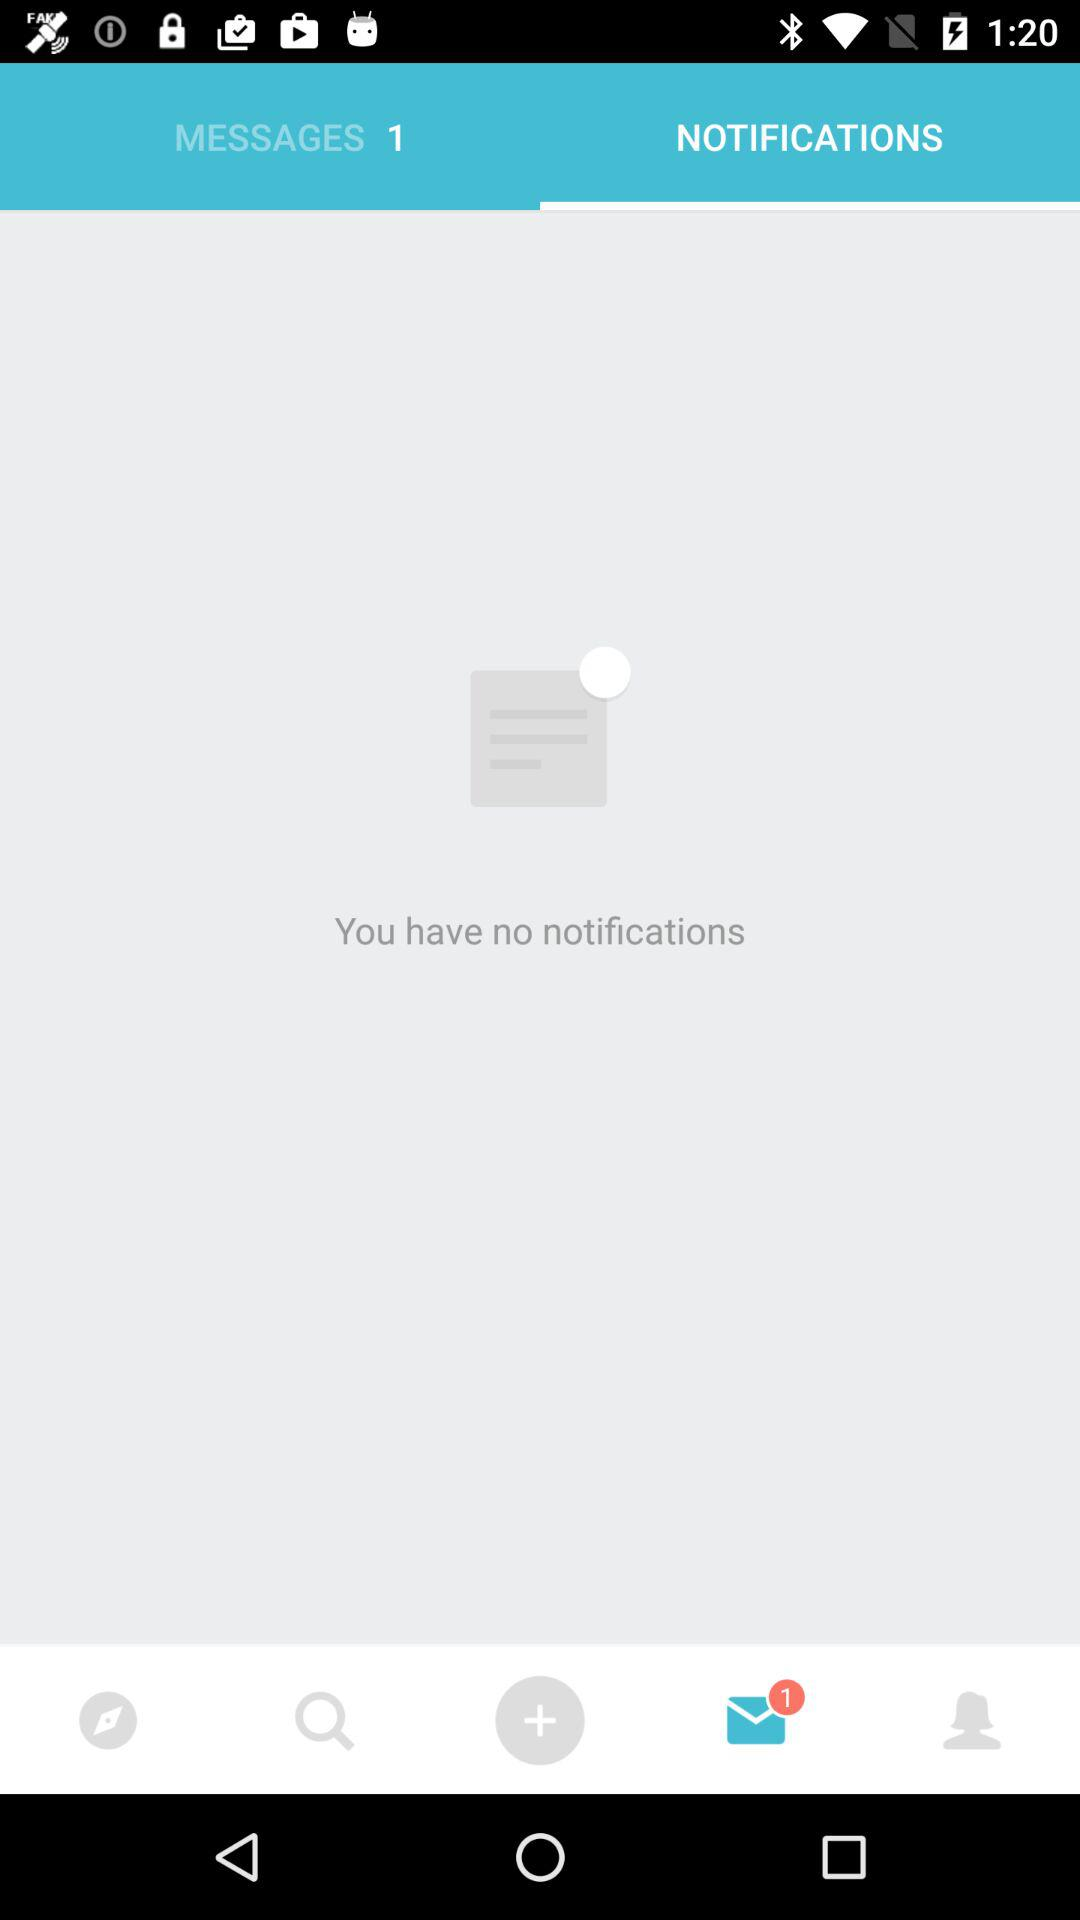Is there any notification? There is no notification. 